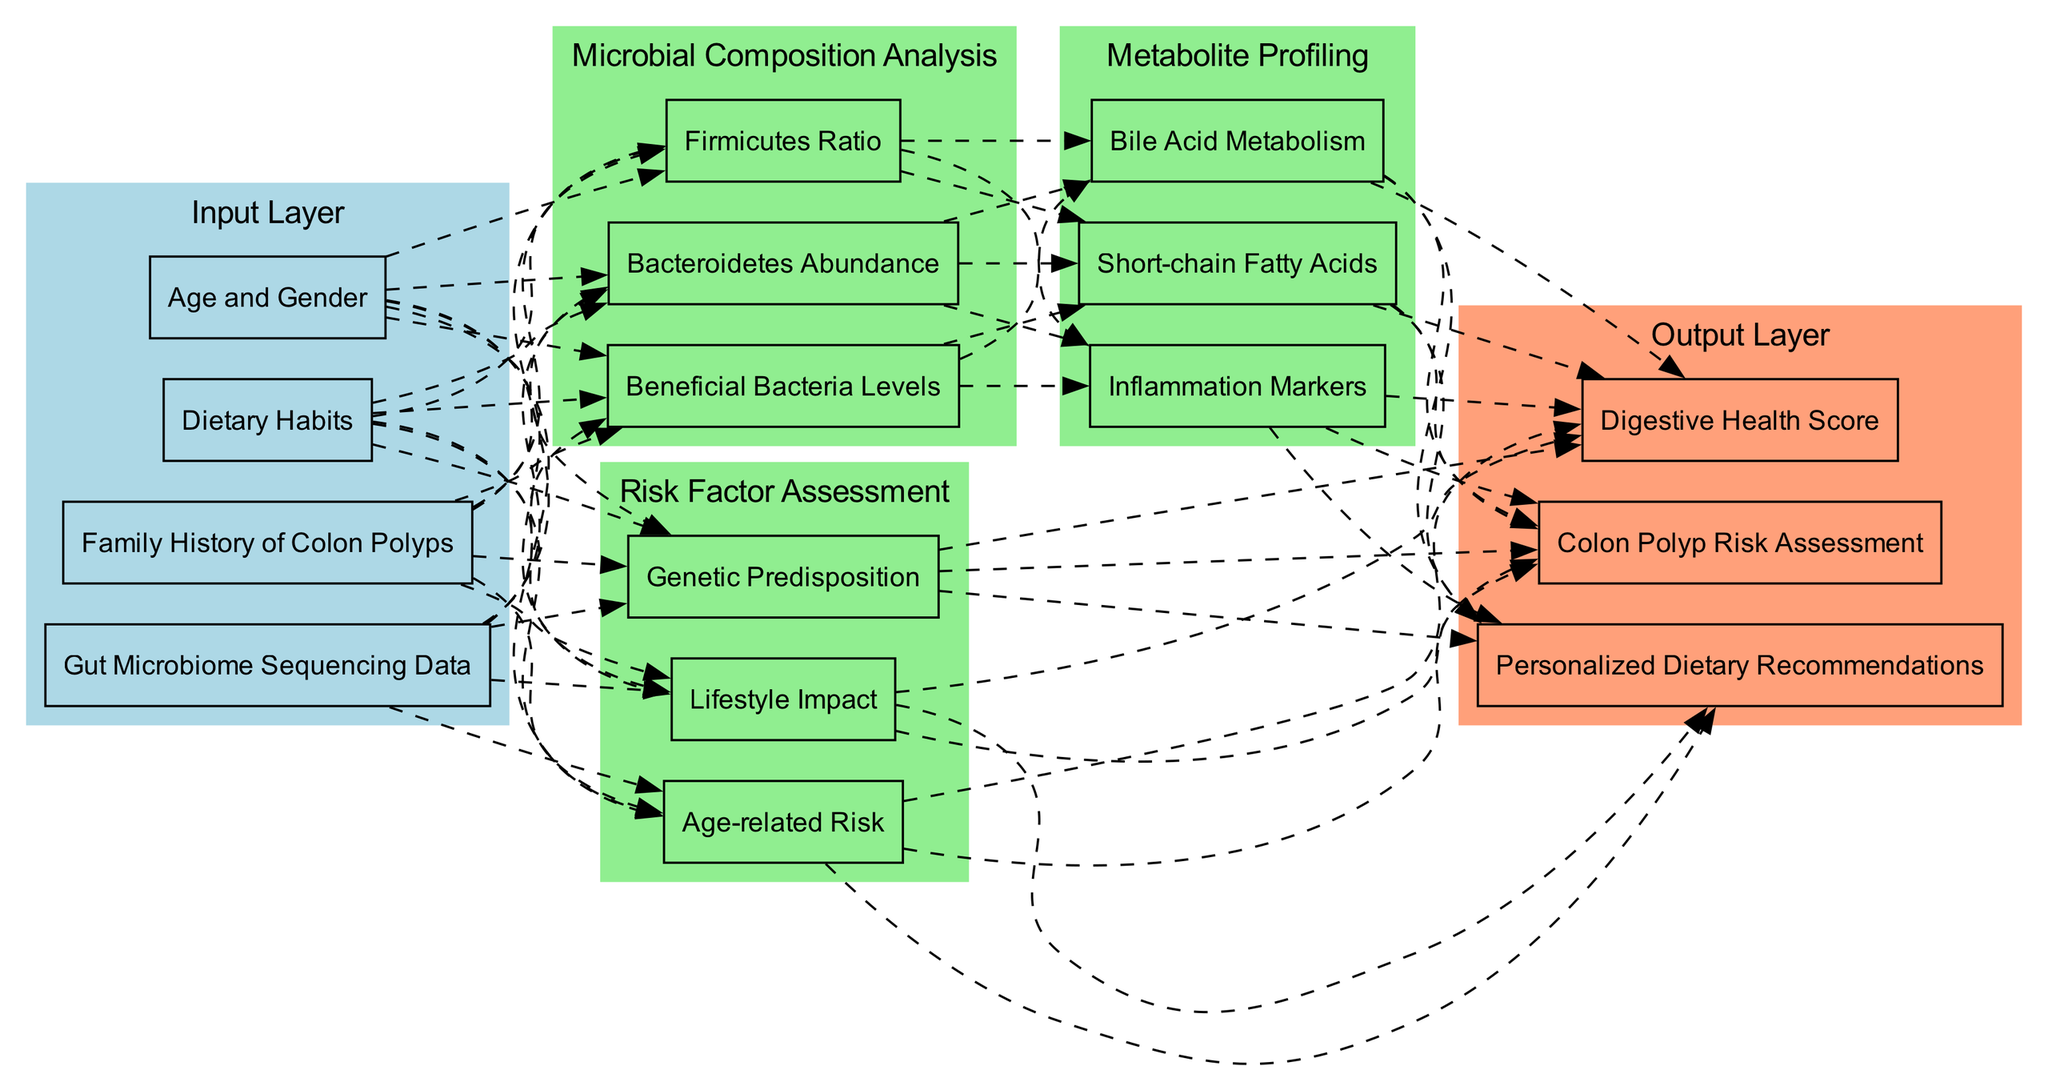What are the nodes in the Input Layer? The Input Layer consists of four nodes: "Gut Microbiome Sequencing Data," "Family History of Colon Polyps," "Dietary Habits," and "Age and Gender."
Answer: Gut Microbiome Sequencing Data, Family History of Colon Polyps, Dietary Habits, Age and Gender How many hidden layers are present in the diagram? There are a total of three hidden layers: "Microbial Composition Analysis," "Risk Factor Assessment," and "Metabolite Profiling."
Answer: 3 What is the last node in the Output Layer? The last node in the Output Layer is "Personalized Dietary Recommendations." Since the Output Layer consists of three nodes and lists them sequentially, the last one is identified as such.
Answer: Personalized Dietary Recommendations Which hidden layer is connected directly to the Output Layer? The "Risk Factor Assessment" and "Metabolite Profiling" hidden layers are both connected directly to the Output Layer. However, since the question asks for one, I can refer to just one of these connected layers.
Answer: Risk Factor Assessment What is the connection type between the Microbial Composition Analysis and the Metabolite Profiling layers? The connection type between the "Microbial Composition Analysis" and "Metabolite Profiling" hidden layers is represented by a dashed line in the diagram. This indicates a non-direct pathway as they share the same structure.
Answer: Dashed Which nodes contribute to the Digestive Health Score in the Output Layer? The nodes that contribute to the Digestive Health Score are derived from both the "Risk Factor Assessment" and the "Metabolite Profiling" layers, making it a combination of information from multiple sources.
Answer: Risk Factor Assessment, Metabolite Profiling What is the first node in the Microbial Composition Analysis hidden layer? The first node in the "Microbial Composition Analysis" hidden layer is "Bacteroidetes Abundance." It can be identified as the first in the list of nodes under this specific hidden layer.
Answer: Bacteroidetes Abundance Which input node influences the microbial composition analysis? The "Gut Microbiome Sequencing Data" input node influences the "Microbial Composition Analysis" hidden layer directly as indicated by the dashed lines connecting them in the diagram.
Answer: Gut Microbiome Sequencing Data How many connections are there from the Input Layer to the hidden layers? There are four total connections from the Input Layer to the hidden layers, since each of the input nodes connects to both "Microbial Composition Analysis" and "Risk Factor Assessment."
Answer: 4 